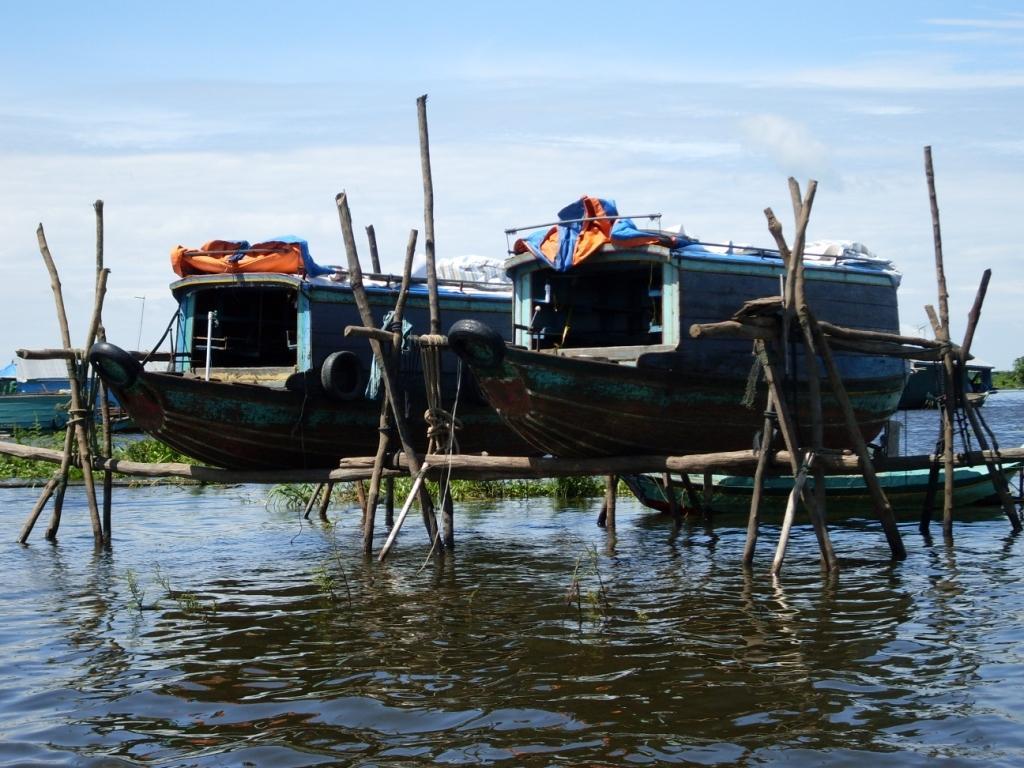Describe this image in one or two sentences. In this picture we can see a boat on water and two boats on sticks, trees and in the background we can see the sky with clouds. 